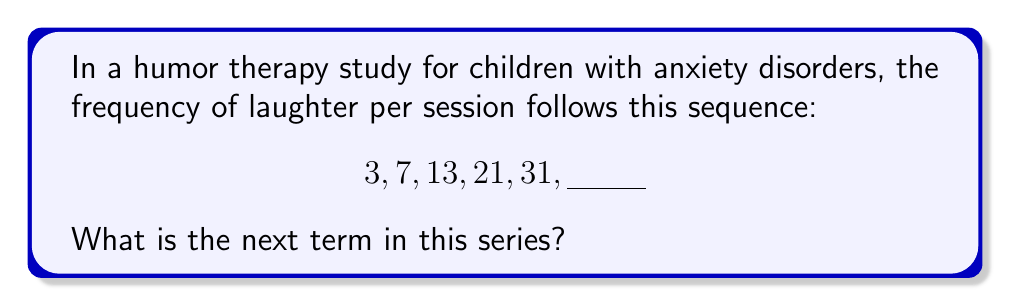Give your solution to this math problem. To find the next term in this sequence, we need to identify the pattern:

1) First, let's calculate the differences between consecutive terms:
   $7 - 3 = 4$
   $13 - 7 = 6$
   $21 - 13 = 8$
   $31 - 21 = 10$

2) We observe that the differences form an arithmetic sequence: 4, 6, 8, 10
   The common difference of this arithmetic sequence is 2.

3) We can express the nth difference as: $d_n = 2n + 2$, where n starts at 0.

4) To get the next term, we need to add the next difference to the last term:
   Next difference: $d_4 = 2(4) + 2 = 10$

5) Therefore, the next term will be:
   $31 + (2(4) + 2) = 31 + 10 = 41$

This pattern suggests that as therapy sessions progress, the frequency of laughter increases at an accelerating rate, which could indicate improving effectiveness of the humor therapy for anxiety reduction.
Answer: 41 